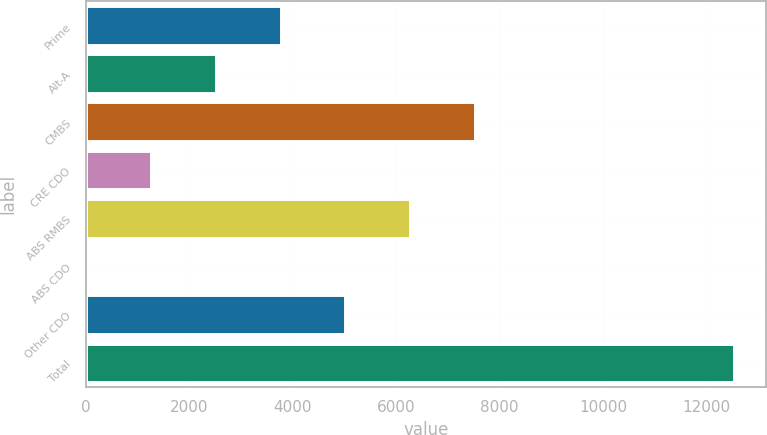Convert chart. <chart><loc_0><loc_0><loc_500><loc_500><bar_chart><fcel>Prime<fcel>Alt-A<fcel>CMBS<fcel>CRE CDO<fcel>ABS RMBS<fcel>ABS CDO<fcel>Other CDO<fcel>Total<nl><fcel>3764.2<fcel>2512.8<fcel>7518.4<fcel>1261.4<fcel>6267<fcel>10<fcel>5015.6<fcel>12524<nl></chart> 